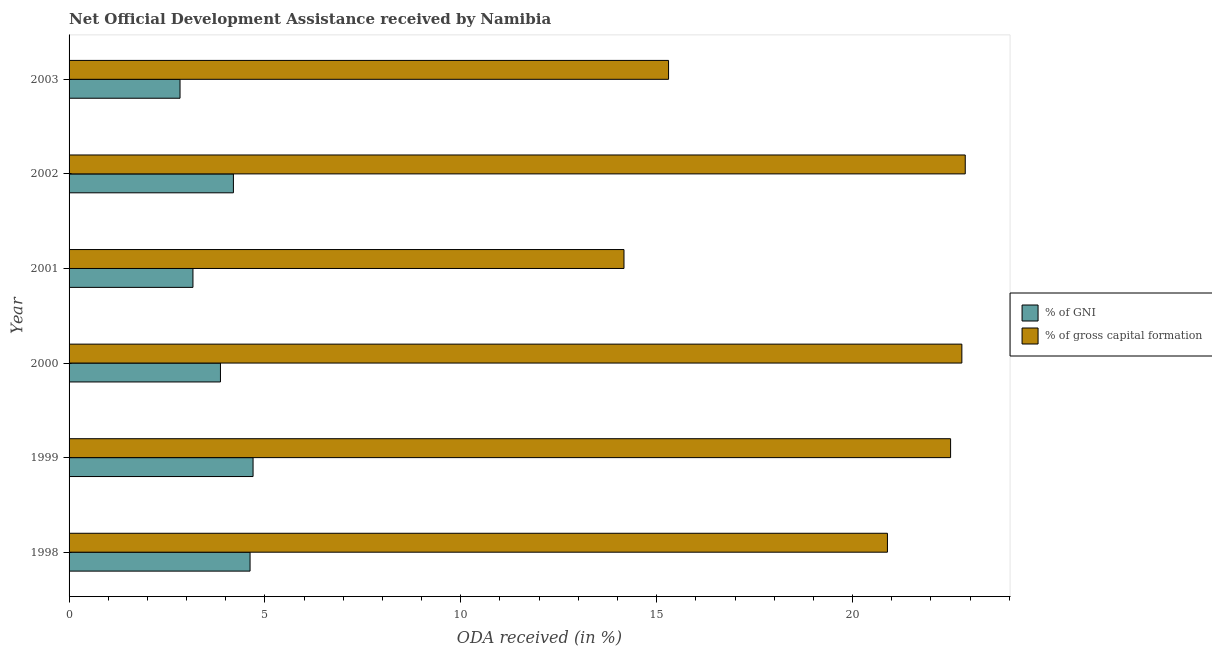Are the number of bars on each tick of the Y-axis equal?
Your answer should be very brief. Yes. How many bars are there on the 1st tick from the top?
Provide a succinct answer. 2. How many bars are there on the 2nd tick from the bottom?
Provide a short and direct response. 2. What is the oda received as percentage of gross capital formation in 2000?
Your answer should be compact. 22.79. Across all years, what is the maximum oda received as percentage of gross capital formation?
Give a very brief answer. 22.88. Across all years, what is the minimum oda received as percentage of gross capital formation?
Your response must be concise. 14.17. What is the total oda received as percentage of gross capital formation in the graph?
Your response must be concise. 118.53. What is the difference between the oda received as percentage of gni in 2001 and that in 2002?
Make the answer very short. -1.03. What is the difference between the oda received as percentage of gross capital formation in 2000 and the oda received as percentage of gni in 1999?
Provide a succinct answer. 18.09. What is the average oda received as percentage of gross capital formation per year?
Keep it short and to the point. 19.75. In the year 1999, what is the difference between the oda received as percentage of gni and oda received as percentage of gross capital formation?
Keep it short and to the point. -17.81. In how many years, is the oda received as percentage of gross capital formation greater than 17 %?
Ensure brevity in your answer.  4. What is the ratio of the oda received as percentage of gross capital formation in 1998 to that in 2003?
Ensure brevity in your answer.  1.36. Is the difference between the oda received as percentage of gni in 2001 and 2002 greater than the difference between the oda received as percentage of gross capital formation in 2001 and 2002?
Offer a terse response. Yes. What is the difference between the highest and the second highest oda received as percentage of gross capital formation?
Make the answer very short. 0.09. What is the difference between the highest and the lowest oda received as percentage of gross capital formation?
Offer a terse response. 8.71. In how many years, is the oda received as percentage of gross capital formation greater than the average oda received as percentage of gross capital formation taken over all years?
Offer a terse response. 4. Is the sum of the oda received as percentage of gni in 1998 and 2003 greater than the maximum oda received as percentage of gross capital formation across all years?
Make the answer very short. No. What does the 1st bar from the top in 1998 represents?
Offer a terse response. % of gross capital formation. What does the 1st bar from the bottom in 2003 represents?
Provide a short and direct response. % of GNI. How many years are there in the graph?
Offer a terse response. 6. Does the graph contain any zero values?
Provide a succinct answer. No. Does the graph contain grids?
Give a very brief answer. No. Where does the legend appear in the graph?
Give a very brief answer. Center right. How are the legend labels stacked?
Offer a very short reply. Vertical. What is the title of the graph?
Keep it short and to the point. Net Official Development Assistance received by Namibia. What is the label or title of the X-axis?
Your answer should be very brief. ODA received (in %). What is the label or title of the Y-axis?
Your answer should be very brief. Year. What is the ODA received (in %) in % of GNI in 1998?
Offer a very short reply. 4.62. What is the ODA received (in %) in % of gross capital formation in 1998?
Offer a terse response. 20.89. What is the ODA received (in %) of % of GNI in 1999?
Give a very brief answer. 4.7. What is the ODA received (in %) in % of gross capital formation in 1999?
Your answer should be compact. 22.5. What is the ODA received (in %) of % of GNI in 2000?
Your response must be concise. 3.86. What is the ODA received (in %) in % of gross capital formation in 2000?
Ensure brevity in your answer.  22.79. What is the ODA received (in %) of % of GNI in 2001?
Make the answer very short. 3.16. What is the ODA received (in %) of % of gross capital formation in 2001?
Your answer should be very brief. 14.17. What is the ODA received (in %) of % of GNI in 2002?
Your answer should be compact. 4.19. What is the ODA received (in %) of % of gross capital formation in 2002?
Provide a short and direct response. 22.88. What is the ODA received (in %) of % of GNI in 2003?
Your answer should be compact. 2.83. What is the ODA received (in %) of % of gross capital formation in 2003?
Provide a short and direct response. 15.3. Across all years, what is the maximum ODA received (in %) of % of GNI?
Provide a succinct answer. 4.7. Across all years, what is the maximum ODA received (in %) in % of gross capital formation?
Ensure brevity in your answer.  22.88. Across all years, what is the minimum ODA received (in %) of % of GNI?
Give a very brief answer. 2.83. Across all years, what is the minimum ODA received (in %) of % of gross capital formation?
Keep it short and to the point. 14.17. What is the total ODA received (in %) in % of GNI in the graph?
Ensure brevity in your answer.  23.37. What is the total ODA received (in %) in % of gross capital formation in the graph?
Ensure brevity in your answer.  118.53. What is the difference between the ODA received (in %) of % of GNI in 1998 and that in 1999?
Provide a succinct answer. -0.08. What is the difference between the ODA received (in %) in % of gross capital formation in 1998 and that in 1999?
Provide a succinct answer. -1.61. What is the difference between the ODA received (in %) of % of GNI in 1998 and that in 2000?
Your answer should be compact. 0.76. What is the difference between the ODA received (in %) of % of gross capital formation in 1998 and that in 2000?
Your answer should be compact. -1.9. What is the difference between the ODA received (in %) of % of GNI in 1998 and that in 2001?
Your answer should be very brief. 1.46. What is the difference between the ODA received (in %) in % of gross capital formation in 1998 and that in 2001?
Your answer should be compact. 6.72. What is the difference between the ODA received (in %) in % of GNI in 1998 and that in 2002?
Ensure brevity in your answer.  0.42. What is the difference between the ODA received (in %) in % of gross capital formation in 1998 and that in 2002?
Your response must be concise. -1.99. What is the difference between the ODA received (in %) of % of GNI in 1998 and that in 2003?
Provide a short and direct response. 1.79. What is the difference between the ODA received (in %) in % of gross capital formation in 1998 and that in 2003?
Your answer should be very brief. 5.59. What is the difference between the ODA received (in %) in % of GNI in 1999 and that in 2000?
Your answer should be very brief. 0.83. What is the difference between the ODA received (in %) of % of gross capital formation in 1999 and that in 2000?
Provide a short and direct response. -0.29. What is the difference between the ODA received (in %) in % of GNI in 1999 and that in 2001?
Give a very brief answer. 1.53. What is the difference between the ODA received (in %) of % of gross capital formation in 1999 and that in 2001?
Provide a short and direct response. 8.34. What is the difference between the ODA received (in %) of % of GNI in 1999 and that in 2002?
Offer a very short reply. 0.5. What is the difference between the ODA received (in %) of % of gross capital formation in 1999 and that in 2002?
Keep it short and to the point. -0.37. What is the difference between the ODA received (in %) in % of GNI in 1999 and that in 2003?
Provide a succinct answer. 1.86. What is the difference between the ODA received (in %) in % of gross capital formation in 1999 and that in 2003?
Keep it short and to the point. 7.2. What is the difference between the ODA received (in %) in % of GNI in 2000 and that in 2001?
Make the answer very short. 0.7. What is the difference between the ODA received (in %) of % of gross capital formation in 2000 and that in 2001?
Provide a short and direct response. 8.62. What is the difference between the ODA received (in %) in % of GNI in 2000 and that in 2002?
Your answer should be very brief. -0.33. What is the difference between the ODA received (in %) of % of gross capital formation in 2000 and that in 2002?
Provide a short and direct response. -0.09. What is the difference between the ODA received (in %) in % of GNI in 2000 and that in 2003?
Offer a very short reply. 1.03. What is the difference between the ODA received (in %) of % of gross capital formation in 2000 and that in 2003?
Your answer should be compact. 7.49. What is the difference between the ODA received (in %) of % of GNI in 2001 and that in 2002?
Your answer should be compact. -1.03. What is the difference between the ODA received (in %) of % of gross capital formation in 2001 and that in 2002?
Offer a terse response. -8.71. What is the difference between the ODA received (in %) in % of GNI in 2001 and that in 2003?
Ensure brevity in your answer.  0.33. What is the difference between the ODA received (in %) in % of gross capital formation in 2001 and that in 2003?
Ensure brevity in your answer.  -1.14. What is the difference between the ODA received (in %) of % of GNI in 2002 and that in 2003?
Make the answer very short. 1.36. What is the difference between the ODA received (in %) in % of gross capital formation in 2002 and that in 2003?
Offer a very short reply. 7.57. What is the difference between the ODA received (in %) of % of GNI in 1998 and the ODA received (in %) of % of gross capital formation in 1999?
Keep it short and to the point. -17.88. What is the difference between the ODA received (in %) of % of GNI in 1998 and the ODA received (in %) of % of gross capital formation in 2000?
Ensure brevity in your answer.  -18.17. What is the difference between the ODA received (in %) in % of GNI in 1998 and the ODA received (in %) in % of gross capital formation in 2001?
Provide a short and direct response. -9.54. What is the difference between the ODA received (in %) of % of GNI in 1998 and the ODA received (in %) of % of gross capital formation in 2002?
Provide a short and direct response. -18.26. What is the difference between the ODA received (in %) in % of GNI in 1998 and the ODA received (in %) in % of gross capital formation in 2003?
Keep it short and to the point. -10.68. What is the difference between the ODA received (in %) of % of GNI in 1999 and the ODA received (in %) of % of gross capital formation in 2000?
Provide a short and direct response. -18.09. What is the difference between the ODA received (in %) in % of GNI in 1999 and the ODA received (in %) in % of gross capital formation in 2001?
Keep it short and to the point. -9.47. What is the difference between the ODA received (in %) in % of GNI in 1999 and the ODA received (in %) in % of gross capital formation in 2002?
Make the answer very short. -18.18. What is the difference between the ODA received (in %) of % of GNI in 1999 and the ODA received (in %) of % of gross capital formation in 2003?
Give a very brief answer. -10.61. What is the difference between the ODA received (in %) in % of GNI in 2000 and the ODA received (in %) in % of gross capital formation in 2001?
Give a very brief answer. -10.3. What is the difference between the ODA received (in %) of % of GNI in 2000 and the ODA received (in %) of % of gross capital formation in 2002?
Provide a succinct answer. -19.01. What is the difference between the ODA received (in %) in % of GNI in 2000 and the ODA received (in %) in % of gross capital formation in 2003?
Offer a terse response. -11.44. What is the difference between the ODA received (in %) of % of GNI in 2001 and the ODA received (in %) of % of gross capital formation in 2002?
Your answer should be compact. -19.71. What is the difference between the ODA received (in %) in % of GNI in 2001 and the ODA received (in %) in % of gross capital formation in 2003?
Your answer should be compact. -12.14. What is the difference between the ODA received (in %) of % of GNI in 2002 and the ODA received (in %) of % of gross capital formation in 2003?
Provide a succinct answer. -11.11. What is the average ODA received (in %) in % of GNI per year?
Your response must be concise. 3.9. What is the average ODA received (in %) in % of gross capital formation per year?
Keep it short and to the point. 19.75. In the year 1998, what is the difference between the ODA received (in %) in % of GNI and ODA received (in %) in % of gross capital formation?
Ensure brevity in your answer.  -16.27. In the year 1999, what is the difference between the ODA received (in %) in % of GNI and ODA received (in %) in % of gross capital formation?
Offer a terse response. -17.81. In the year 2000, what is the difference between the ODA received (in %) in % of GNI and ODA received (in %) in % of gross capital formation?
Your answer should be very brief. -18.93. In the year 2001, what is the difference between the ODA received (in %) of % of GNI and ODA received (in %) of % of gross capital formation?
Provide a succinct answer. -11. In the year 2002, what is the difference between the ODA received (in %) in % of GNI and ODA received (in %) in % of gross capital formation?
Offer a very short reply. -18.68. In the year 2003, what is the difference between the ODA received (in %) in % of GNI and ODA received (in %) in % of gross capital formation?
Offer a very short reply. -12.47. What is the ratio of the ODA received (in %) in % of GNI in 1998 to that in 1999?
Ensure brevity in your answer.  0.98. What is the ratio of the ODA received (in %) of % of gross capital formation in 1998 to that in 1999?
Offer a very short reply. 0.93. What is the ratio of the ODA received (in %) of % of GNI in 1998 to that in 2000?
Provide a succinct answer. 1.2. What is the ratio of the ODA received (in %) of % of gross capital formation in 1998 to that in 2000?
Ensure brevity in your answer.  0.92. What is the ratio of the ODA received (in %) of % of GNI in 1998 to that in 2001?
Offer a terse response. 1.46. What is the ratio of the ODA received (in %) of % of gross capital formation in 1998 to that in 2001?
Provide a succinct answer. 1.47. What is the ratio of the ODA received (in %) of % of GNI in 1998 to that in 2002?
Give a very brief answer. 1.1. What is the ratio of the ODA received (in %) of % of gross capital formation in 1998 to that in 2002?
Ensure brevity in your answer.  0.91. What is the ratio of the ODA received (in %) in % of GNI in 1998 to that in 2003?
Provide a succinct answer. 1.63. What is the ratio of the ODA received (in %) in % of gross capital formation in 1998 to that in 2003?
Your answer should be compact. 1.37. What is the ratio of the ODA received (in %) of % of GNI in 1999 to that in 2000?
Give a very brief answer. 1.22. What is the ratio of the ODA received (in %) of % of gross capital formation in 1999 to that in 2000?
Ensure brevity in your answer.  0.99. What is the ratio of the ODA received (in %) of % of GNI in 1999 to that in 2001?
Your answer should be very brief. 1.49. What is the ratio of the ODA received (in %) of % of gross capital formation in 1999 to that in 2001?
Ensure brevity in your answer.  1.59. What is the ratio of the ODA received (in %) in % of GNI in 1999 to that in 2002?
Offer a very short reply. 1.12. What is the ratio of the ODA received (in %) of % of gross capital formation in 1999 to that in 2002?
Provide a short and direct response. 0.98. What is the ratio of the ODA received (in %) in % of GNI in 1999 to that in 2003?
Provide a short and direct response. 1.66. What is the ratio of the ODA received (in %) in % of gross capital formation in 1999 to that in 2003?
Provide a succinct answer. 1.47. What is the ratio of the ODA received (in %) in % of GNI in 2000 to that in 2001?
Provide a succinct answer. 1.22. What is the ratio of the ODA received (in %) in % of gross capital formation in 2000 to that in 2001?
Your answer should be very brief. 1.61. What is the ratio of the ODA received (in %) of % of GNI in 2000 to that in 2002?
Offer a very short reply. 0.92. What is the ratio of the ODA received (in %) in % of gross capital formation in 2000 to that in 2002?
Ensure brevity in your answer.  1. What is the ratio of the ODA received (in %) of % of GNI in 2000 to that in 2003?
Your answer should be compact. 1.36. What is the ratio of the ODA received (in %) in % of gross capital formation in 2000 to that in 2003?
Ensure brevity in your answer.  1.49. What is the ratio of the ODA received (in %) in % of GNI in 2001 to that in 2002?
Your answer should be very brief. 0.75. What is the ratio of the ODA received (in %) of % of gross capital formation in 2001 to that in 2002?
Provide a succinct answer. 0.62. What is the ratio of the ODA received (in %) of % of GNI in 2001 to that in 2003?
Keep it short and to the point. 1.12. What is the ratio of the ODA received (in %) of % of gross capital formation in 2001 to that in 2003?
Your response must be concise. 0.93. What is the ratio of the ODA received (in %) of % of GNI in 2002 to that in 2003?
Your response must be concise. 1.48. What is the ratio of the ODA received (in %) in % of gross capital formation in 2002 to that in 2003?
Your answer should be compact. 1.49. What is the difference between the highest and the second highest ODA received (in %) of % of GNI?
Offer a very short reply. 0.08. What is the difference between the highest and the second highest ODA received (in %) in % of gross capital formation?
Ensure brevity in your answer.  0.09. What is the difference between the highest and the lowest ODA received (in %) in % of GNI?
Provide a short and direct response. 1.86. What is the difference between the highest and the lowest ODA received (in %) of % of gross capital formation?
Keep it short and to the point. 8.71. 